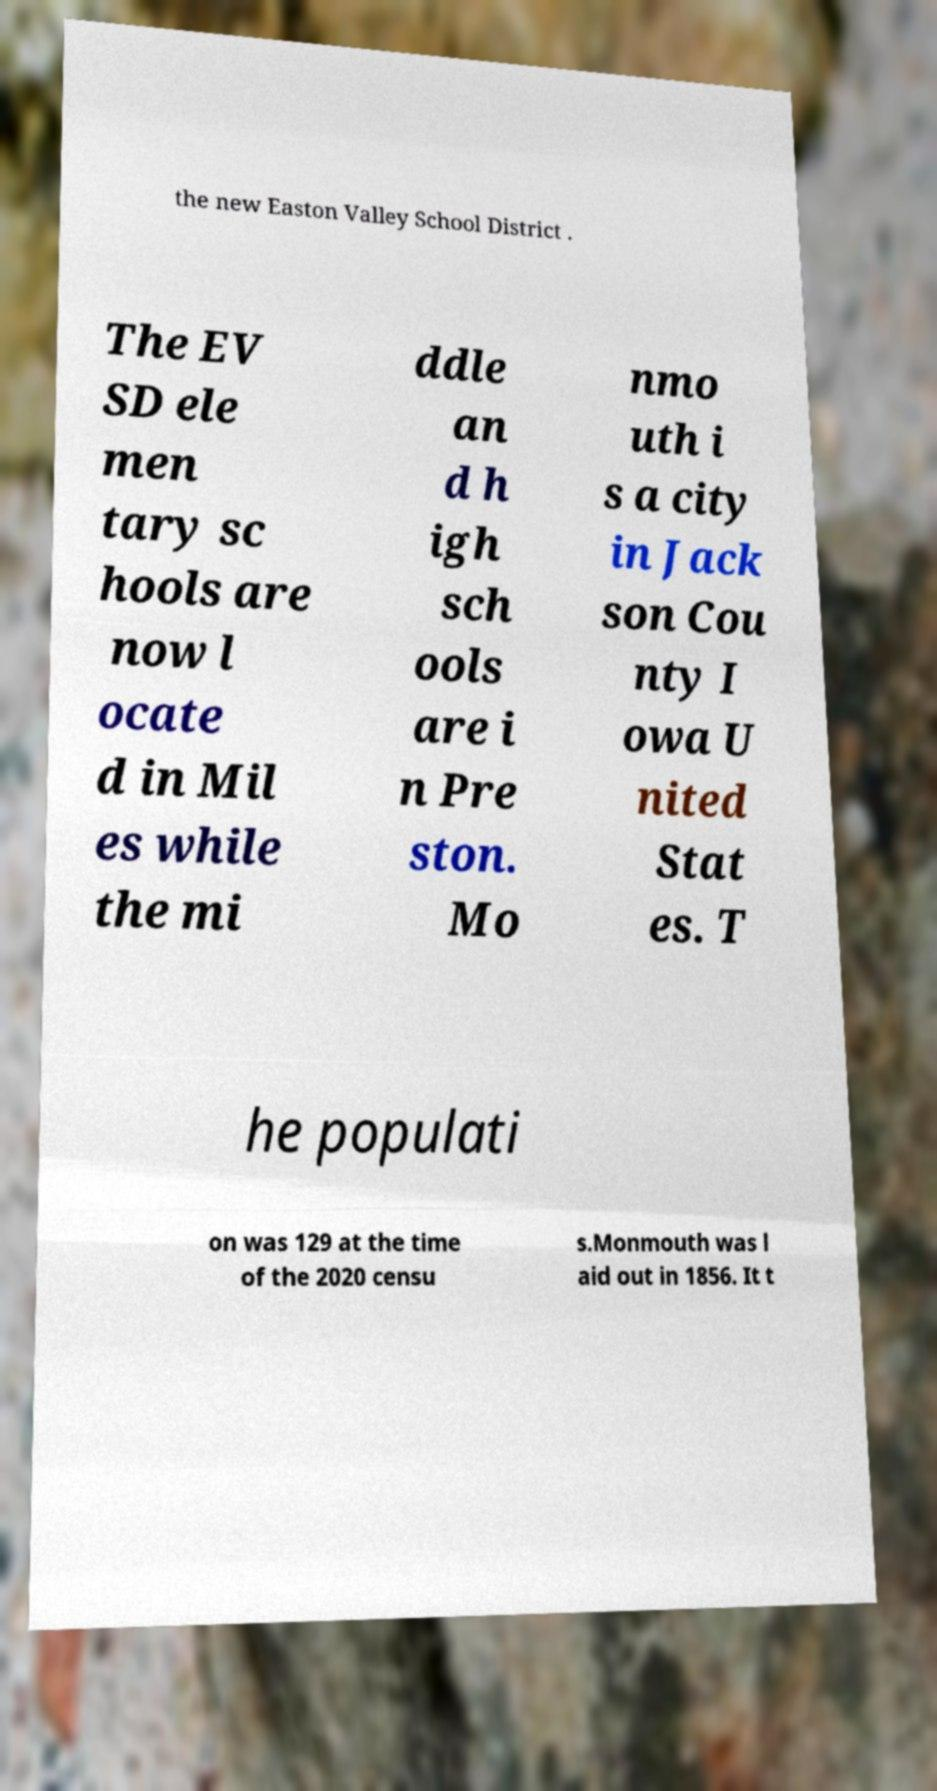There's text embedded in this image that I need extracted. Can you transcribe it verbatim? the new Easton Valley School District . The EV SD ele men tary sc hools are now l ocate d in Mil es while the mi ddle an d h igh sch ools are i n Pre ston. Mo nmo uth i s a city in Jack son Cou nty I owa U nited Stat es. T he populati on was 129 at the time of the 2020 censu s.Monmouth was l aid out in 1856. It t 